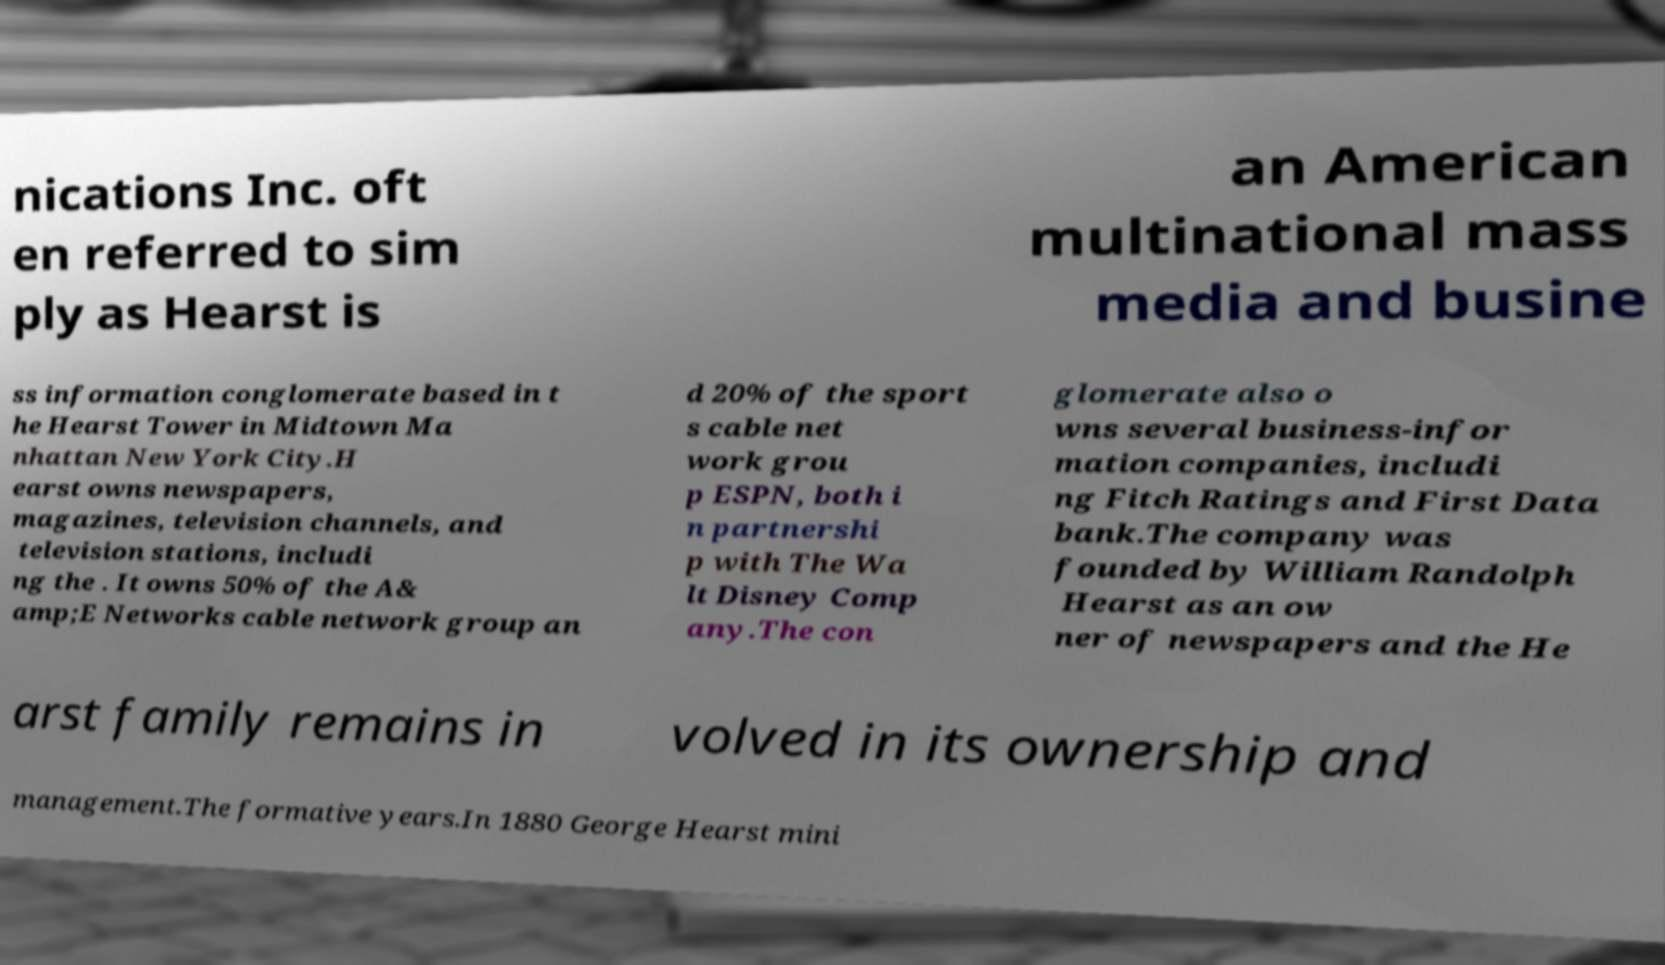Can you read and provide the text displayed in the image?This photo seems to have some interesting text. Can you extract and type it out for me? nications Inc. oft en referred to sim ply as Hearst is an American multinational mass media and busine ss information conglomerate based in t he Hearst Tower in Midtown Ma nhattan New York City.H earst owns newspapers, magazines, television channels, and television stations, includi ng the . It owns 50% of the A& amp;E Networks cable network group an d 20% of the sport s cable net work grou p ESPN, both i n partnershi p with The Wa lt Disney Comp any.The con glomerate also o wns several business-infor mation companies, includi ng Fitch Ratings and First Data bank.The company was founded by William Randolph Hearst as an ow ner of newspapers and the He arst family remains in volved in its ownership and management.The formative years.In 1880 George Hearst mini 